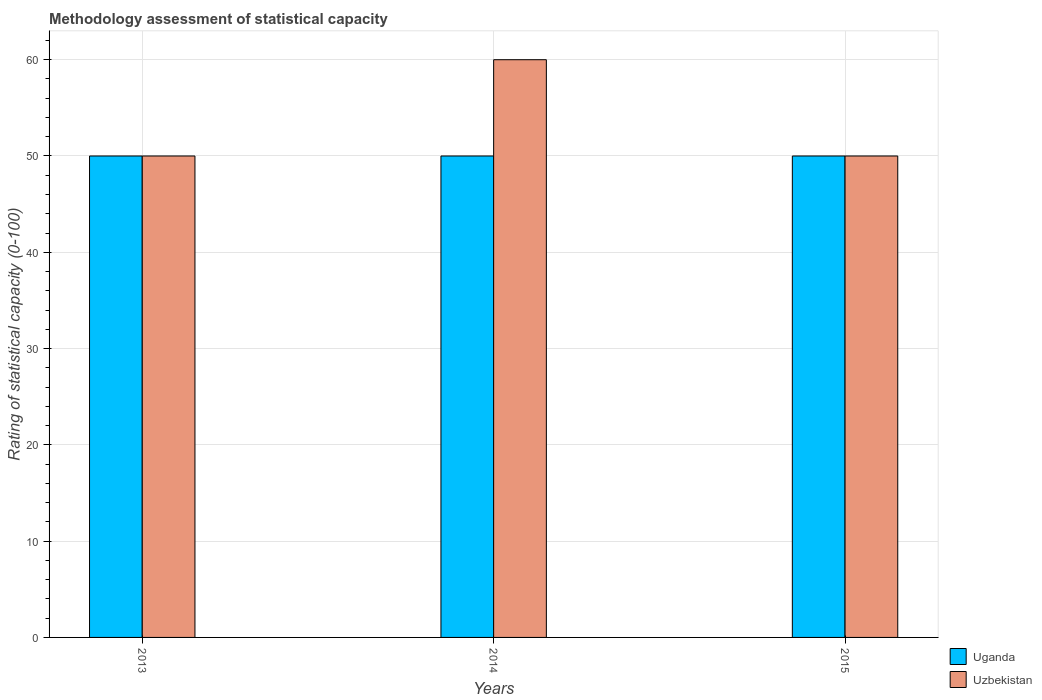How many different coloured bars are there?
Offer a terse response. 2. How many groups of bars are there?
Your response must be concise. 3. How many bars are there on the 1st tick from the left?
Offer a terse response. 2. In how many cases, is the number of bars for a given year not equal to the number of legend labels?
Offer a very short reply. 0. What is the rating of statistical capacity in Uganda in 2014?
Offer a very short reply. 50. Across all years, what is the maximum rating of statistical capacity in Uzbekistan?
Provide a short and direct response. 60. Across all years, what is the minimum rating of statistical capacity in Uzbekistan?
Your answer should be compact. 50. In which year was the rating of statistical capacity in Uzbekistan maximum?
Your answer should be compact. 2014. In which year was the rating of statistical capacity in Uganda minimum?
Your answer should be very brief. 2013. What is the total rating of statistical capacity in Uzbekistan in the graph?
Keep it short and to the point. 160. What is the difference between the rating of statistical capacity in Uzbekistan in 2014 and the rating of statistical capacity in Uganda in 2013?
Your answer should be very brief. 10. What is the average rating of statistical capacity in Uzbekistan per year?
Keep it short and to the point. 53.33. In how many years, is the rating of statistical capacity in Uganda greater than 12?
Offer a terse response. 3. What is the ratio of the rating of statistical capacity in Uzbekistan in 2013 to that in 2015?
Your answer should be compact. 1. What is the difference between the highest and the lowest rating of statistical capacity in Uganda?
Your answer should be very brief. 0. In how many years, is the rating of statistical capacity in Uganda greater than the average rating of statistical capacity in Uganda taken over all years?
Your answer should be very brief. 0. What does the 1st bar from the left in 2013 represents?
Ensure brevity in your answer.  Uganda. What does the 1st bar from the right in 2015 represents?
Offer a very short reply. Uzbekistan. How many years are there in the graph?
Provide a succinct answer. 3. How many legend labels are there?
Provide a succinct answer. 2. How are the legend labels stacked?
Your answer should be very brief. Vertical. What is the title of the graph?
Your answer should be very brief. Methodology assessment of statistical capacity. Does "OECD members" appear as one of the legend labels in the graph?
Offer a very short reply. No. What is the label or title of the X-axis?
Offer a terse response. Years. What is the label or title of the Y-axis?
Your answer should be very brief. Rating of statistical capacity (0-100). What is the Rating of statistical capacity (0-100) of Uzbekistan in 2013?
Provide a succinct answer. 50. What is the Rating of statistical capacity (0-100) of Uganda in 2014?
Your response must be concise. 50. What is the Rating of statistical capacity (0-100) of Uzbekistan in 2014?
Offer a terse response. 60. What is the Rating of statistical capacity (0-100) of Uzbekistan in 2015?
Ensure brevity in your answer.  50. Across all years, what is the maximum Rating of statistical capacity (0-100) of Uzbekistan?
Offer a terse response. 60. Across all years, what is the minimum Rating of statistical capacity (0-100) in Uganda?
Offer a very short reply. 50. What is the total Rating of statistical capacity (0-100) in Uganda in the graph?
Give a very brief answer. 150. What is the total Rating of statistical capacity (0-100) in Uzbekistan in the graph?
Offer a very short reply. 160. What is the difference between the Rating of statistical capacity (0-100) in Uzbekistan in 2013 and that in 2014?
Offer a terse response. -10. What is the difference between the Rating of statistical capacity (0-100) in Uganda in 2014 and that in 2015?
Provide a short and direct response. 0. What is the difference between the Rating of statistical capacity (0-100) in Uzbekistan in 2014 and that in 2015?
Provide a succinct answer. 10. What is the difference between the Rating of statistical capacity (0-100) of Uganda in 2013 and the Rating of statistical capacity (0-100) of Uzbekistan in 2015?
Ensure brevity in your answer.  0. What is the average Rating of statistical capacity (0-100) in Uzbekistan per year?
Provide a succinct answer. 53.33. In the year 2013, what is the difference between the Rating of statistical capacity (0-100) in Uganda and Rating of statistical capacity (0-100) in Uzbekistan?
Offer a terse response. 0. What is the ratio of the Rating of statistical capacity (0-100) in Uganda in 2013 to that in 2014?
Your response must be concise. 1. What is the ratio of the Rating of statistical capacity (0-100) of Uzbekistan in 2013 to that in 2014?
Your answer should be very brief. 0.83. What is the ratio of the Rating of statistical capacity (0-100) in Uganda in 2013 to that in 2015?
Offer a terse response. 1. What is the ratio of the Rating of statistical capacity (0-100) in Uzbekistan in 2013 to that in 2015?
Make the answer very short. 1. What is the ratio of the Rating of statistical capacity (0-100) in Uganda in 2014 to that in 2015?
Provide a succinct answer. 1. What is the ratio of the Rating of statistical capacity (0-100) in Uzbekistan in 2014 to that in 2015?
Provide a short and direct response. 1.2. What is the difference between the highest and the second highest Rating of statistical capacity (0-100) of Uganda?
Make the answer very short. 0. What is the difference between the highest and the second highest Rating of statistical capacity (0-100) in Uzbekistan?
Your answer should be very brief. 10. 